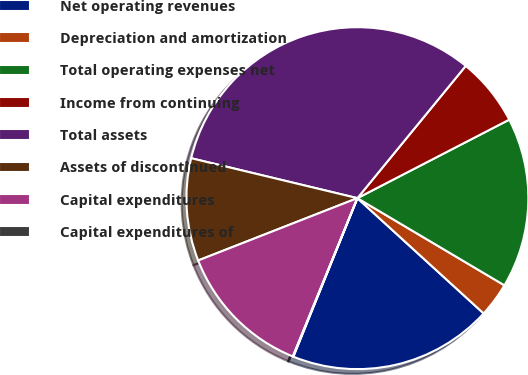Convert chart to OTSL. <chart><loc_0><loc_0><loc_500><loc_500><pie_chart><fcel>Net operating revenues<fcel>Depreciation and amortization<fcel>Total operating expenses net<fcel>Income from continuing<fcel>Total assets<fcel>Assets of discontinued<fcel>Capital expenditures<fcel>Capital expenditures of<nl><fcel>19.33%<fcel>3.26%<fcel>16.11%<fcel>6.48%<fcel>32.17%<fcel>9.69%<fcel>12.9%<fcel>0.05%<nl></chart> 